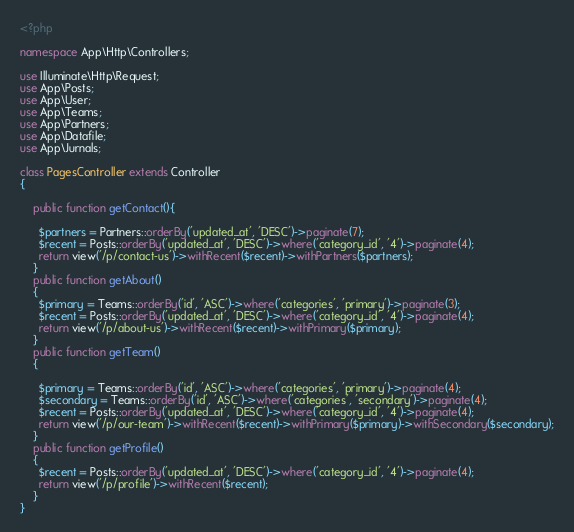<code> <loc_0><loc_0><loc_500><loc_500><_PHP_><?php

namespace App\Http\Controllers;

use Illuminate\Http\Request;
use App\Posts;
use App\User;
use App\Teams;
use App\Partners;
use App\Datafile;
use App\Jurnals;

class PagesController extends Controller
{

    public function getContact(){

      $partners = Partners::orderBy('updated_at', 'DESC')->paginate(7);
      $recent = Posts::orderBy('updated_at', 'DESC')->where('category_id', '4')->paginate(4);
      return view('/p/contact-us')->withRecent($recent)->withPartners($partners);
    }
    public function getAbout()
    {
      $primary = Teams::orderBy('id', 'ASC')->where('categories', 'primary')->paginate(3);
      $recent = Posts::orderBy('updated_at', 'DESC')->where('category_id', '4')->paginate(4);
      return view('/p/about-us')->withRecent($recent)->withPrimary($primary);
    }
    public function getTeam()
    {

      $primary = Teams::orderBy('id', 'ASC')->where('categories', 'primary')->paginate(4);
      $secondary = Teams::orderBy('id', 'ASC')->where('categories', 'secondary')->paginate(4);
      $recent = Posts::orderBy('updated_at', 'DESC')->where('category_id', '4')->paginate(4);
      return view('/p/our-team')->withRecent($recent)->withPrimary($primary)->withSecondary($secondary);
    }
    public function getProfile()
    {
      $recent = Posts::orderBy('updated_at', 'DESC')->where('category_id', '4')->paginate(4);
      return view('/p/profile')->withRecent($recent);
    }
}
</code> 